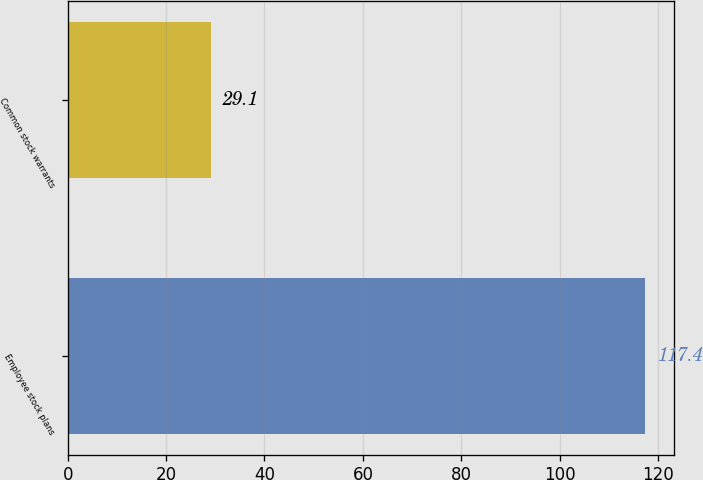<chart> <loc_0><loc_0><loc_500><loc_500><bar_chart><fcel>Employee stock plans<fcel>Common stock warrants<nl><fcel>117.4<fcel>29.1<nl></chart> 